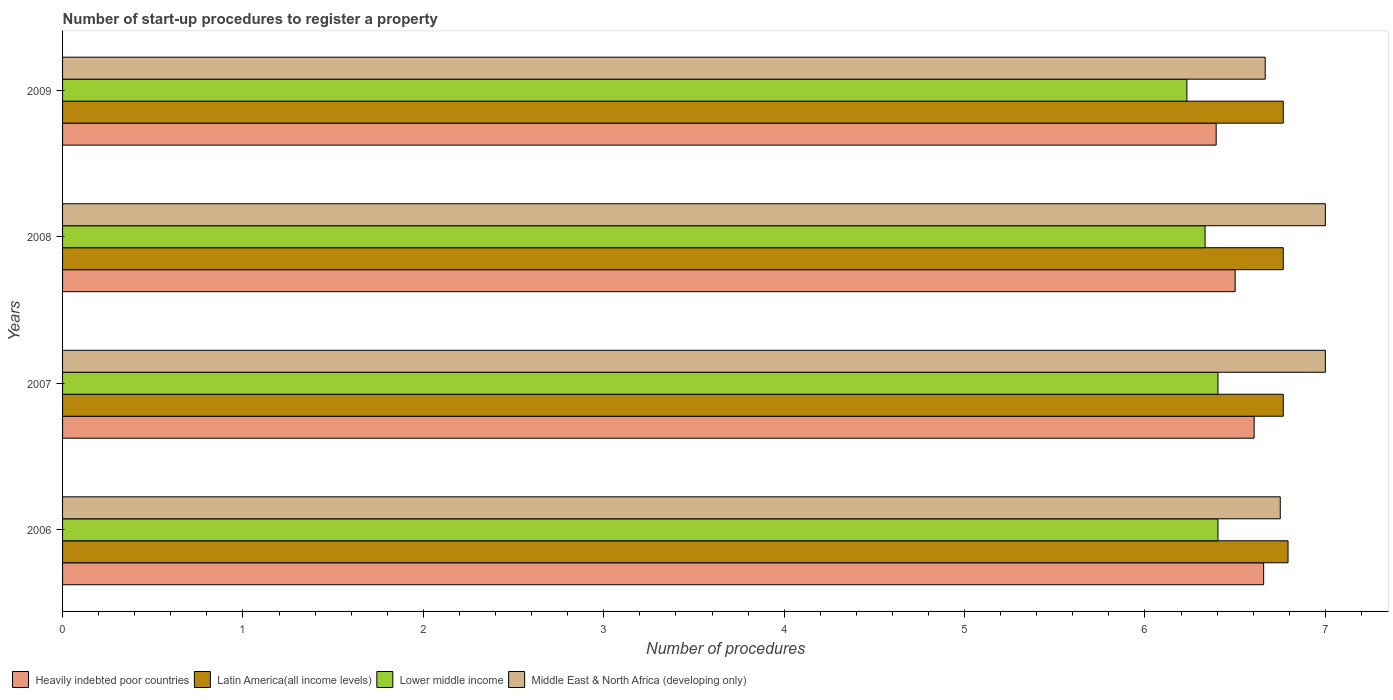How many different coloured bars are there?
Keep it short and to the point. 4. How many bars are there on the 1st tick from the bottom?
Your response must be concise. 4. In how many cases, is the number of bars for a given year not equal to the number of legend labels?
Give a very brief answer. 0. What is the number of procedures required to register a property in Middle East & North Africa (developing only) in 2009?
Keep it short and to the point. 6.67. Across all years, what is the maximum number of procedures required to register a property in Latin America(all income levels)?
Offer a terse response. 6.79. Across all years, what is the minimum number of procedures required to register a property in Middle East & North Africa (developing only)?
Your answer should be compact. 6.67. In which year was the number of procedures required to register a property in Latin America(all income levels) maximum?
Give a very brief answer. 2006. What is the total number of procedures required to register a property in Middle East & North Africa (developing only) in the graph?
Provide a succinct answer. 27.42. What is the difference between the number of procedures required to register a property in Middle East & North Africa (developing only) in 2007 and that in 2008?
Offer a very short reply. 0. What is the difference between the number of procedures required to register a property in Heavily indebted poor countries in 2006 and the number of procedures required to register a property in Latin America(all income levels) in 2009?
Keep it short and to the point. -0.11. What is the average number of procedures required to register a property in Middle East & North Africa (developing only) per year?
Ensure brevity in your answer.  6.85. In the year 2009, what is the difference between the number of procedures required to register a property in Middle East & North Africa (developing only) and number of procedures required to register a property in Heavily indebted poor countries?
Your response must be concise. 0.27. What is the ratio of the number of procedures required to register a property in Lower middle income in 2007 to that in 2009?
Your response must be concise. 1.03. Is the number of procedures required to register a property in Heavily indebted poor countries in 2007 less than that in 2008?
Your answer should be compact. No. Is the difference between the number of procedures required to register a property in Middle East & North Africa (developing only) in 2006 and 2009 greater than the difference between the number of procedures required to register a property in Heavily indebted poor countries in 2006 and 2009?
Provide a succinct answer. No. What is the difference between the highest and the lowest number of procedures required to register a property in Lower middle income?
Make the answer very short. 0.17. Is the sum of the number of procedures required to register a property in Middle East & North Africa (developing only) in 2008 and 2009 greater than the maximum number of procedures required to register a property in Lower middle income across all years?
Offer a very short reply. Yes. Is it the case that in every year, the sum of the number of procedures required to register a property in Middle East & North Africa (developing only) and number of procedures required to register a property in Lower middle income is greater than the sum of number of procedures required to register a property in Heavily indebted poor countries and number of procedures required to register a property in Latin America(all income levels)?
Keep it short and to the point. No. What does the 4th bar from the top in 2009 represents?
Offer a very short reply. Heavily indebted poor countries. What does the 1st bar from the bottom in 2008 represents?
Provide a short and direct response. Heavily indebted poor countries. How many bars are there?
Ensure brevity in your answer.  16. What is the difference between two consecutive major ticks on the X-axis?
Make the answer very short. 1. Are the values on the major ticks of X-axis written in scientific E-notation?
Offer a terse response. No. Does the graph contain any zero values?
Give a very brief answer. No. Does the graph contain grids?
Give a very brief answer. No. How many legend labels are there?
Ensure brevity in your answer.  4. What is the title of the graph?
Ensure brevity in your answer.  Number of start-up procedures to register a property. What is the label or title of the X-axis?
Make the answer very short. Number of procedures. What is the label or title of the Y-axis?
Provide a succinct answer. Years. What is the Number of procedures of Heavily indebted poor countries in 2006?
Your answer should be compact. 6.66. What is the Number of procedures of Latin America(all income levels) in 2006?
Make the answer very short. 6.79. What is the Number of procedures in Lower middle income in 2006?
Provide a succinct answer. 6.4. What is the Number of procedures of Middle East & North Africa (developing only) in 2006?
Your answer should be very brief. 6.75. What is the Number of procedures in Heavily indebted poor countries in 2007?
Offer a very short reply. 6.61. What is the Number of procedures of Latin America(all income levels) in 2007?
Offer a terse response. 6.77. What is the Number of procedures of Lower middle income in 2007?
Make the answer very short. 6.4. What is the Number of procedures of Heavily indebted poor countries in 2008?
Your response must be concise. 6.5. What is the Number of procedures in Latin America(all income levels) in 2008?
Give a very brief answer. 6.77. What is the Number of procedures of Lower middle income in 2008?
Ensure brevity in your answer.  6.33. What is the Number of procedures in Heavily indebted poor countries in 2009?
Make the answer very short. 6.39. What is the Number of procedures of Latin America(all income levels) in 2009?
Keep it short and to the point. 6.77. What is the Number of procedures of Lower middle income in 2009?
Make the answer very short. 6.23. What is the Number of procedures of Middle East & North Africa (developing only) in 2009?
Provide a short and direct response. 6.67. Across all years, what is the maximum Number of procedures in Heavily indebted poor countries?
Your response must be concise. 6.66. Across all years, what is the maximum Number of procedures in Latin America(all income levels)?
Your answer should be compact. 6.79. Across all years, what is the maximum Number of procedures of Lower middle income?
Your response must be concise. 6.4. Across all years, what is the minimum Number of procedures in Heavily indebted poor countries?
Offer a very short reply. 6.39. Across all years, what is the minimum Number of procedures in Latin America(all income levels)?
Make the answer very short. 6.77. Across all years, what is the minimum Number of procedures of Lower middle income?
Your answer should be compact. 6.23. Across all years, what is the minimum Number of procedures of Middle East & North Africa (developing only)?
Make the answer very short. 6.67. What is the total Number of procedures of Heavily indebted poor countries in the graph?
Make the answer very short. 26.16. What is the total Number of procedures of Latin America(all income levels) in the graph?
Offer a very short reply. 27.09. What is the total Number of procedures in Lower middle income in the graph?
Provide a short and direct response. 25.38. What is the total Number of procedures in Middle East & North Africa (developing only) in the graph?
Keep it short and to the point. 27.42. What is the difference between the Number of procedures in Heavily indebted poor countries in 2006 and that in 2007?
Make the answer very short. 0.05. What is the difference between the Number of procedures in Latin America(all income levels) in 2006 and that in 2007?
Your response must be concise. 0.03. What is the difference between the Number of procedures in Middle East & North Africa (developing only) in 2006 and that in 2007?
Offer a very short reply. -0.25. What is the difference between the Number of procedures in Heavily indebted poor countries in 2006 and that in 2008?
Keep it short and to the point. 0.16. What is the difference between the Number of procedures in Latin America(all income levels) in 2006 and that in 2008?
Provide a succinct answer. 0.03. What is the difference between the Number of procedures of Lower middle income in 2006 and that in 2008?
Your answer should be compact. 0.07. What is the difference between the Number of procedures of Heavily indebted poor countries in 2006 and that in 2009?
Offer a very short reply. 0.26. What is the difference between the Number of procedures of Latin America(all income levels) in 2006 and that in 2009?
Give a very brief answer. 0.03. What is the difference between the Number of procedures in Lower middle income in 2006 and that in 2009?
Ensure brevity in your answer.  0.17. What is the difference between the Number of procedures of Middle East & North Africa (developing only) in 2006 and that in 2009?
Your answer should be compact. 0.08. What is the difference between the Number of procedures of Heavily indebted poor countries in 2007 and that in 2008?
Your answer should be compact. 0.11. What is the difference between the Number of procedures of Lower middle income in 2007 and that in 2008?
Your answer should be very brief. 0.07. What is the difference between the Number of procedures of Middle East & North Africa (developing only) in 2007 and that in 2008?
Provide a short and direct response. 0. What is the difference between the Number of procedures of Heavily indebted poor countries in 2007 and that in 2009?
Offer a terse response. 0.21. What is the difference between the Number of procedures of Lower middle income in 2007 and that in 2009?
Your answer should be compact. 0.17. What is the difference between the Number of procedures in Middle East & North Africa (developing only) in 2007 and that in 2009?
Your response must be concise. 0.33. What is the difference between the Number of procedures of Heavily indebted poor countries in 2008 and that in 2009?
Make the answer very short. 0.11. What is the difference between the Number of procedures of Latin America(all income levels) in 2008 and that in 2009?
Ensure brevity in your answer.  0. What is the difference between the Number of procedures of Lower middle income in 2008 and that in 2009?
Your answer should be compact. 0.1. What is the difference between the Number of procedures in Heavily indebted poor countries in 2006 and the Number of procedures in Latin America(all income levels) in 2007?
Keep it short and to the point. -0.11. What is the difference between the Number of procedures of Heavily indebted poor countries in 2006 and the Number of procedures of Lower middle income in 2007?
Keep it short and to the point. 0.25. What is the difference between the Number of procedures of Heavily indebted poor countries in 2006 and the Number of procedures of Middle East & North Africa (developing only) in 2007?
Your response must be concise. -0.34. What is the difference between the Number of procedures in Latin America(all income levels) in 2006 and the Number of procedures in Lower middle income in 2007?
Keep it short and to the point. 0.39. What is the difference between the Number of procedures of Latin America(all income levels) in 2006 and the Number of procedures of Middle East & North Africa (developing only) in 2007?
Make the answer very short. -0.21. What is the difference between the Number of procedures in Lower middle income in 2006 and the Number of procedures in Middle East & North Africa (developing only) in 2007?
Offer a very short reply. -0.6. What is the difference between the Number of procedures in Heavily indebted poor countries in 2006 and the Number of procedures in Latin America(all income levels) in 2008?
Provide a short and direct response. -0.11. What is the difference between the Number of procedures in Heavily indebted poor countries in 2006 and the Number of procedures in Lower middle income in 2008?
Give a very brief answer. 0.32. What is the difference between the Number of procedures of Heavily indebted poor countries in 2006 and the Number of procedures of Middle East & North Africa (developing only) in 2008?
Give a very brief answer. -0.34. What is the difference between the Number of procedures in Latin America(all income levels) in 2006 and the Number of procedures in Lower middle income in 2008?
Give a very brief answer. 0.46. What is the difference between the Number of procedures of Latin America(all income levels) in 2006 and the Number of procedures of Middle East & North Africa (developing only) in 2008?
Offer a very short reply. -0.21. What is the difference between the Number of procedures in Lower middle income in 2006 and the Number of procedures in Middle East & North Africa (developing only) in 2008?
Make the answer very short. -0.6. What is the difference between the Number of procedures of Heavily indebted poor countries in 2006 and the Number of procedures of Latin America(all income levels) in 2009?
Your answer should be compact. -0.11. What is the difference between the Number of procedures of Heavily indebted poor countries in 2006 and the Number of procedures of Lower middle income in 2009?
Your answer should be compact. 0.43. What is the difference between the Number of procedures of Heavily indebted poor countries in 2006 and the Number of procedures of Middle East & North Africa (developing only) in 2009?
Keep it short and to the point. -0.01. What is the difference between the Number of procedures in Latin America(all income levels) in 2006 and the Number of procedures in Lower middle income in 2009?
Ensure brevity in your answer.  0.56. What is the difference between the Number of procedures in Latin America(all income levels) in 2006 and the Number of procedures in Middle East & North Africa (developing only) in 2009?
Make the answer very short. 0.13. What is the difference between the Number of procedures in Lower middle income in 2006 and the Number of procedures in Middle East & North Africa (developing only) in 2009?
Make the answer very short. -0.26. What is the difference between the Number of procedures in Heavily indebted poor countries in 2007 and the Number of procedures in Latin America(all income levels) in 2008?
Provide a succinct answer. -0.16. What is the difference between the Number of procedures in Heavily indebted poor countries in 2007 and the Number of procedures in Lower middle income in 2008?
Make the answer very short. 0.27. What is the difference between the Number of procedures in Heavily indebted poor countries in 2007 and the Number of procedures in Middle East & North Africa (developing only) in 2008?
Your answer should be very brief. -0.39. What is the difference between the Number of procedures in Latin America(all income levels) in 2007 and the Number of procedures in Lower middle income in 2008?
Provide a succinct answer. 0.43. What is the difference between the Number of procedures of Latin America(all income levels) in 2007 and the Number of procedures of Middle East & North Africa (developing only) in 2008?
Your response must be concise. -0.23. What is the difference between the Number of procedures in Lower middle income in 2007 and the Number of procedures in Middle East & North Africa (developing only) in 2008?
Provide a short and direct response. -0.6. What is the difference between the Number of procedures of Heavily indebted poor countries in 2007 and the Number of procedures of Latin America(all income levels) in 2009?
Your answer should be compact. -0.16. What is the difference between the Number of procedures in Heavily indebted poor countries in 2007 and the Number of procedures in Lower middle income in 2009?
Give a very brief answer. 0.37. What is the difference between the Number of procedures of Heavily indebted poor countries in 2007 and the Number of procedures of Middle East & North Africa (developing only) in 2009?
Offer a very short reply. -0.06. What is the difference between the Number of procedures in Latin America(all income levels) in 2007 and the Number of procedures in Lower middle income in 2009?
Your response must be concise. 0.53. What is the difference between the Number of procedures of Lower middle income in 2007 and the Number of procedures of Middle East & North Africa (developing only) in 2009?
Ensure brevity in your answer.  -0.26. What is the difference between the Number of procedures of Heavily indebted poor countries in 2008 and the Number of procedures of Latin America(all income levels) in 2009?
Offer a very short reply. -0.27. What is the difference between the Number of procedures of Heavily indebted poor countries in 2008 and the Number of procedures of Lower middle income in 2009?
Your answer should be compact. 0.27. What is the difference between the Number of procedures of Heavily indebted poor countries in 2008 and the Number of procedures of Middle East & North Africa (developing only) in 2009?
Keep it short and to the point. -0.17. What is the difference between the Number of procedures in Latin America(all income levels) in 2008 and the Number of procedures in Lower middle income in 2009?
Provide a succinct answer. 0.53. What is the difference between the Number of procedures of Latin America(all income levels) in 2008 and the Number of procedures of Middle East & North Africa (developing only) in 2009?
Ensure brevity in your answer.  0.1. What is the difference between the Number of procedures in Lower middle income in 2008 and the Number of procedures in Middle East & North Africa (developing only) in 2009?
Ensure brevity in your answer.  -0.33. What is the average Number of procedures of Heavily indebted poor countries per year?
Your answer should be very brief. 6.54. What is the average Number of procedures in Latin America(all income levels) per year?
Your answer should be very brief. 6.77. What is the average Number of procedures in Lower middle income per year?
Your response must be concise. 6.34. What is the average Number of procedures in Middle East & North Africa (developing only) per year?
Your response must be concise. 6.85. In the year 2006, what is the difference between the Number of procedures of Heavily indebted poor countries and Number of procedures of Latin America(all income levels)?
Provide a short and direct response. -0.14. In the year 2006, what is the difference between the Number of procedures of Heavily indebted poor countries and Number of procedures of Lower middle income?
Give a very brief answer. 0.25. In the year 2006, what is the difference between the Number of procedures of Heavily indebted poor countries and Number of procedures of Middle East & North Africa (developing only)?
Provide a short and direct response. -0.09. In the year 2006, what is the difference between the Number of procedures of Latin America(all income levels) and Number of procedures of Lower middle income?
Your answer should be compact. 0.39. In the year 2006, what is the difference between the Number of procedures in Latin America(all income levels) and Number of procedures in Middle East & North Africa (developing only)?
Offer a very short reply. 0.04. In the year 2006, what is the difference between the Number of procedures in Lower middle income and Number of procedures in Middle East & North Africa (developing only)?
Give a very brief answer. -0.35. In the year 2007, what is the difference between the Number of procedures in Heavily indebted poor countries and Number of procedures in Latin America(all income levels)?
Provide a short and direct response. -0.16. In the year 2007, what is the difference between the Number of procedures in Heavily indebted poor countries and Number of procedures in Lower middle income?
Offer a very short reply. 0.2. In the year 2007, what is the difference between the Number of procedures of Heavily indebted poor countries and Number of procedures of Middle East & North Africa (developing only)?
Offer a terse response. -0.39. In the year 2007, what is the difference between the Number of procedures of Latin America(all income levels) and Number of procedures of Lower middle income?
Ensure brevity in your answer.  0.36. In the year 2007, what is the difference between the Number of procedures of Latin America(all income levels) and Number of procedures of Middle East & North Africa (developing only)?
Offer a very short reply. -0.23. In the year 2007, what is the difference between the Number of procedures of Lower middle income and Number of procedures of Middle East & North Africa (developing only)?
Your answer should be compact. -0.6. In the year 2008, what is the difference between the Number of procedures of Heavily indebted poor countries and Number of procedures of Latin America(all income levels)?
Your response must be concise. -0.27. In the year 2008, what is the difference between the Number of procedures of Heavily indebted poor countries and Number of procedures of Lower middle income?
Keep it short and to the point. 0.17. In the year 2008, what is the difference between the Number of procedures of Heavily indebted poor countries and Number of procedures of Middle East & North Africa (developing only)?
Your response must be concise. -0.5. In the year 2008, what is the difference between the Number of procedures of Latin America(all income levels) and Number of procedures of Lower middle income?
Offer a very short reply. 0.43. In the year 2008, what is the difference between the Number of procedures in Latin America(all income levels) and Number of procedures in Middle East & North Africa (developing only)?
Your answer should be very brief. -0.23. In the year 2009, what is the difference between the Number of procedures of Heavily indebted poor countries and Number of procedures of Latin America(all income levels)?
Offer a very short reply. -0.37. In the year 2009, what is the difference between the Number of procedures of Heavily indebted poor countries and Number of procedures of Lower middle income?
Keep it short and to the point. 0.16. In the year 2009, what is the difference between the Number of procedures in Heavily indebted poor countries and Number of procedures in Middle East & North Africa (developing only)?
Give a very brief answer. -0.27. In the year 2009, what is the difference between the Number of procedures of Latin America(all income levels) and Number of procedures of Lower middle income?
Make the answer very short. 0.53. In the year 2009, what is the difference between the Number of procedures of Lower middle income and Number of procedures of Middle East & North Africa (developing only)?
Ensure brevity in your answer.  -0.43. What is the ratio of the Number of procedures in Heavily indebted poor countries in 2006 to that in 2007?
Your response must be concise. 1.01. What is the ratio of the Number of procedures in Lower middle income in 2006 to that in 2007?
Give a very brief answer. 1. What is the ratio of the Number of procedures in Middle East & North Africa (developing only) in 2006 to that in 2007?
Offer a very short reply. 0.96. What is the ratio of the Number of procedures of Heavily indebted poor countries in 2006 to that in 2008?
Your answer should be compact. 1.02. What is the ratio of the Number of procedures in Latin America(all income levels) in 2006 to that in 2008?
Give a very brief answer. 1. What is the ratio of the Number of procedures in Lower middle income in 2006 to that in 2008?
Your answer should be very brief. 1.01. What is the ratio of the Number of procedures of Middle East & North Africa (developing only) in 2006 to that in 2008?
Provide a succinct answer. 0.96. What is the ratio of the Number of procedures of Heavily indebted poor countries in 2006 to that in 2009?
Provide a short and direct response. 1.04. What is the ratio of the Number of procedures in Latin America(all income levels) in 2006 to that in 2009?
Ensure brevity in your answer.  1. What is the ratio of the Number of procedures in Lower middle income in 2006 to that in 2009?
Offer a very short reply. 1.03. What is the ratio of the Number of procedures of Middle East & North Africa (developing only) in 2006 to that in 2009?
Keep it short and to the point. 1.01. What is the ratio of the Number of procedures in Heavily indebted poor countries in 2007 to that in 2008?
Ensure brevity in your answer.  1.02. What is the ratio of the Number of procedures of Latin America(all income levels) in 2007 to that in 2008?
Offer a terse response. 1. What is the ratio of the Number of procedures in Lower middle income in 2007 to that in 2008?
Provide a succinct answer. 1.01. What is the ratio of the Number of procedures in Middle East & North Africa (developing only) in 2007 to that in 2008?
Offer a very short reply. 1. What is the ratio of the Number of procedures of Heavily indebted poor countries in 2007 to that in 2009?
Your answer should be compact. 1.03. What is the ratio of the Number of procedures of Lower middle income in 2007 to that in 2009?
Offer a very short reply. 1.03. What is the ratio of the Number of procedures of Heavily indebted poor countries in 2008 to that in 2009?
Offer a very short reply. 1.02. What is the ratio of the Number of procedures of Lower middle income in 2008 to that in 2009?
Make the answer very short. 1.02. What is the difference between the highest and the second highest Number of procedures in Heavily indebted poor countries?
Offer a terse response. 0.05. What is the difference between the highest and the second highest Number of procedures of Latin America(all income levels)?
Your response must be concise. 0.03. What is the difference between the highest and the second highest Number of procedures in Lower middle income?
Make the answer very short. 0. What is the difference between the highest and the second highest Number of procedures in Middle East & North Africa (developing only)?
Make the answer very short. 0. What is the difference between the highest and the lowest Number of procedures in Heavily indebted poor countries?
Provide a succinct answer. 0.26. What is the difference between the highest and the lowest Number of procedures in Latin America(all income levels)?
Make the answer very short. 0.03. What is the difference between the highest and the lowest Number of procedures of Lower middle income?
Ensure brevity in your answer.  0.17. What is the difference between the highest and the lowest Number of procedures in Middle East & North Africa (developing only)?
Make the answer very short. 0.33. 